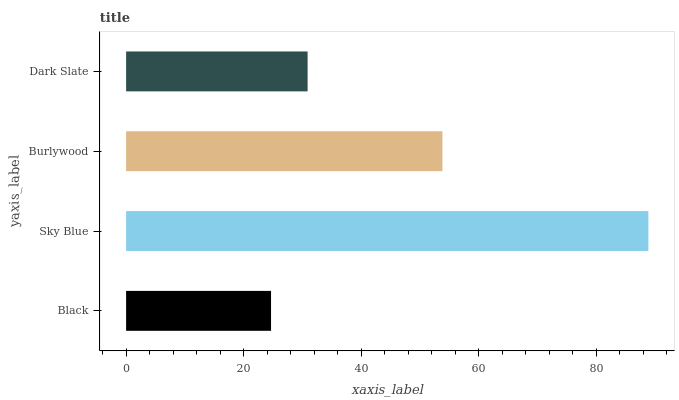Is Black the minimum?
Answer yes or no. Yes. Is Sky Blue the maximum?
Answer yes or no. Yes. Is Burlywood the minimum?
Answer yes or no. No. Is Burlywood the maximum?
Answer yes or no. No. Is Sky Blue greater than Burlywood?
Answer yes or no. Yes. Is Burlywood less than Sky Blue?
Answer yes or no. Yes. Is Burlywood greater than Sky Blue?
Answer yes or no. No. Is Sky Blue less than Burlywood?
Answer yes or no. No. Is Burlywood the high median?
Answer yes or no. Yes. Is Dark Slate the low median?
Answer yes or no. Yes. Is Black the high median?
Answer yes or no. No. Is Sky Blue the low median?
Answer yes or no. No. 